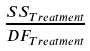Convert formula to latex. <formula><loc_0><loc_0><loc_500><loc_500>\frac { S S _ { T r e a t m e n t } } { D F _ { T r e a t m e n t } }</formula> 